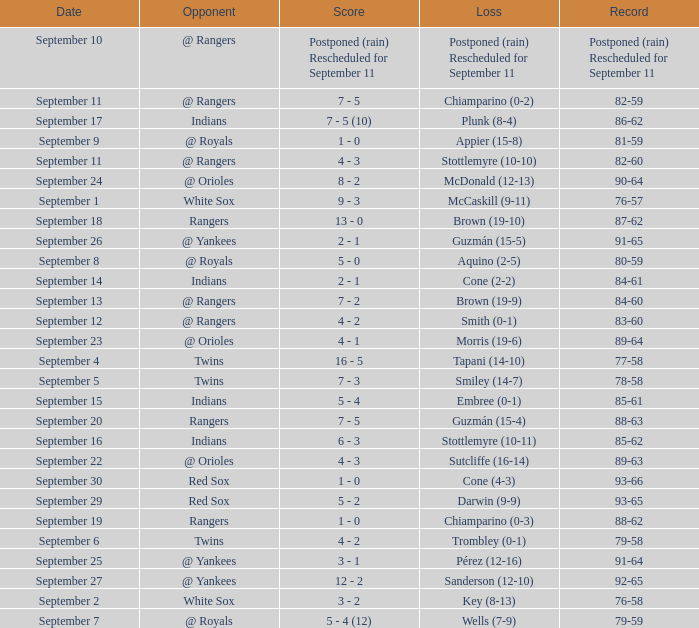What opponent has a loss of McCaskill (9-11)? White Sox. 